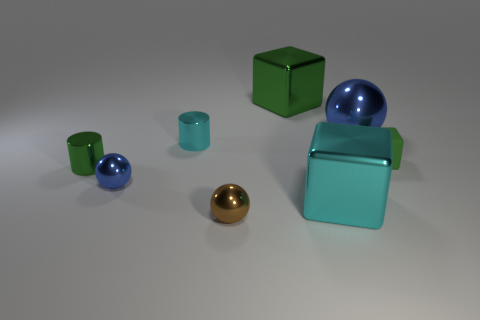What number of metal cylinders are the same color as the rubber object?
Offer a very short reply. 1. What number of things are cyan objects to the left of the tiny brown object or gray cylinders?
Provide a succinct answer. 1. Are there more big blue metal spheres behind the large blue metal ball than blue objects to the right of the big cyan shiny cube?
Provide a short and direct response. No. What number of rubber objects are either small cyan cylinders or tiny purple blocks?
Your response must be concise. 0. There is a big block that is the same color as the tiny rubber block; what material is it?
Make the answer very short. Metal. Are there fewer green rubber blocks behind the big green object than green blocks that are behind the tiny cyan metallic object?
Your response must be concise. Yes. How many things are either tiny green metal things or tiny cylinders in front of the small rubber block?
Your response must be concise. 1. There is a green block that is the same size as the green cylinder; what is its material?
Your answer should be very brief. Rubber. Do the large green block and the big blue sphere have the same material?
Offer a terse response. Yes. There is a large metal thing that is behind the tiny block and left of the big blue metal ball; what is its color?
Your response must be concise. Green. 